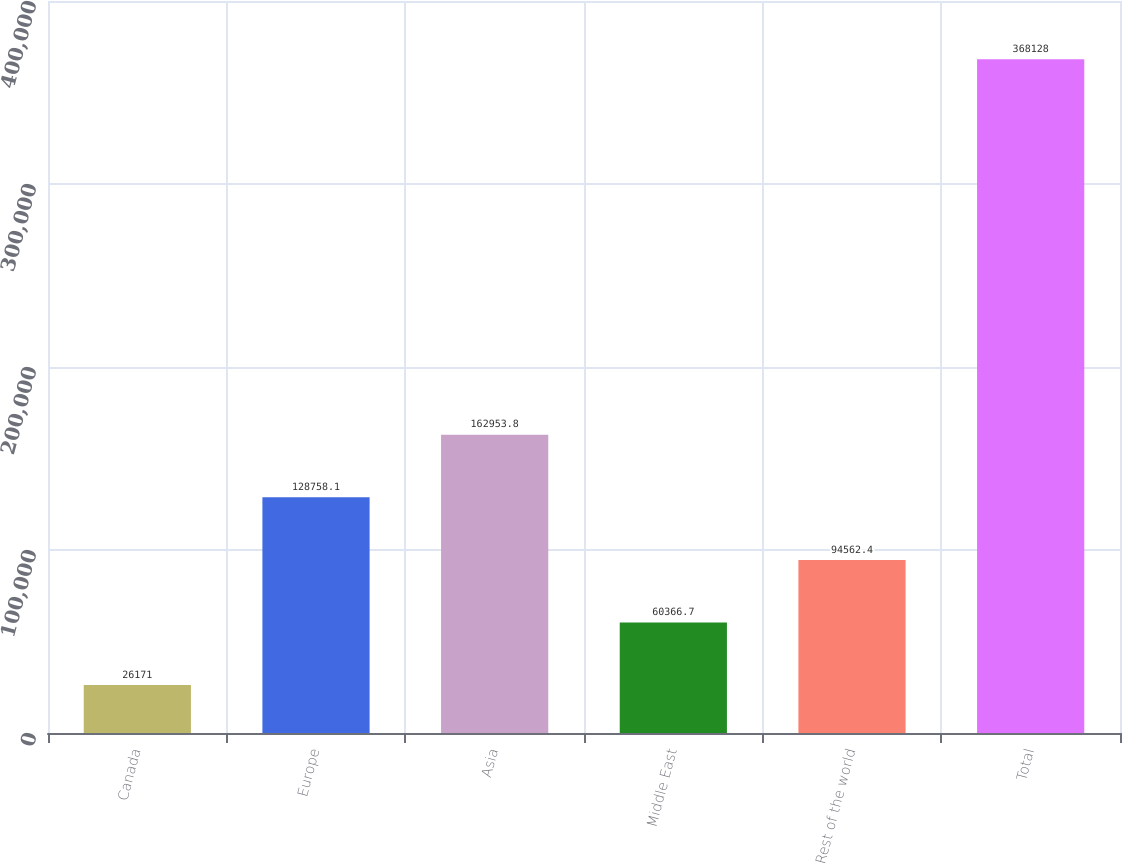<chart> <loc_0><loc_0><loc_500><loc_500><bar_chart><fcel>Canada<fcel>Europe<fcel>Asia<fcel>Middle East<fcel>Rest of the world<fcel>Total<nl><fcel>26171<fcel>128758<fcel>162954<fcel>60366.7<fcel>94562.4<fcel>368128<nl></chart> 